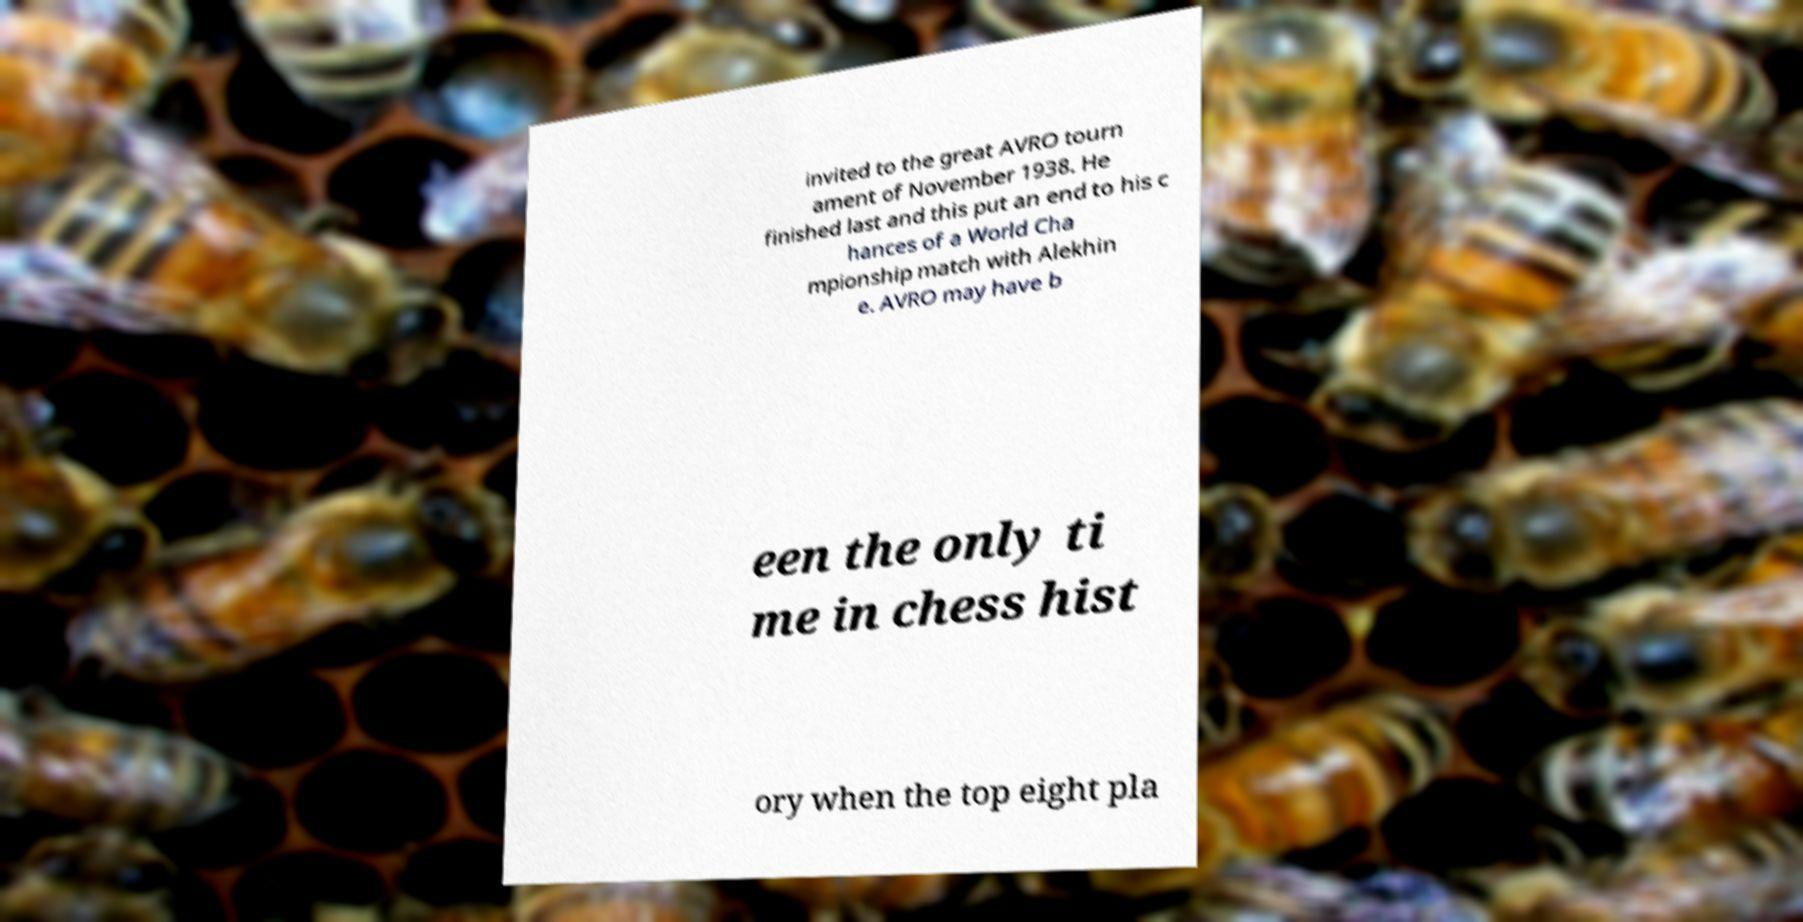For documentation purposes, I need the text within this image transcribed. Could you provide that? invited to the great AVRO tourn ament of November 1938. He finished last and this put an end to his c hances of a World Cha mpionship match with Alekhin e. AVRO may have b een the only ti me in chess hist ory when the top eight pla 